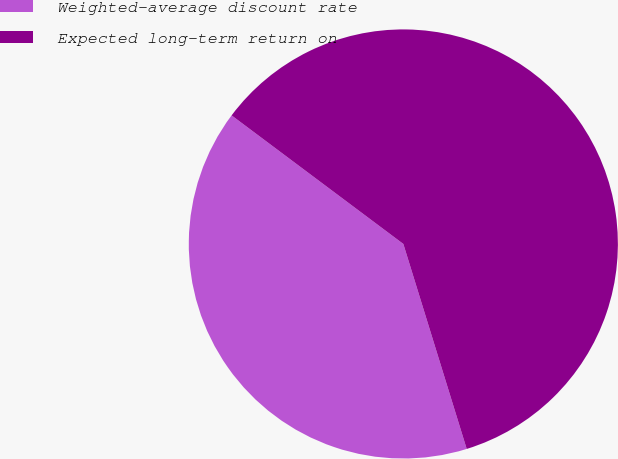Convert chart. <chart><loc_0><loc_0><loc_500><loc_500><pie_chart><fcel>Weighted-average discount rate<fcel>Expected long-term return on<nl><fcel>40.0%<fcel>60.0%<nl></chart> 